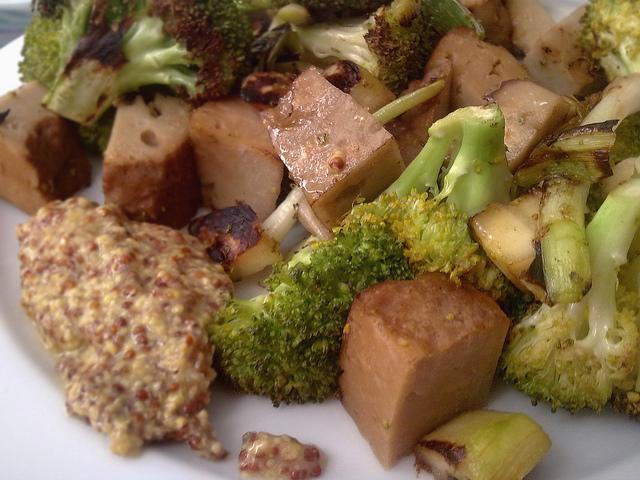What is the color of the plate?
Answer briefly. White. What is the green vegetable?
Write a very short answer. Broccoli. How many plates are there?
Answer briefly. 1. 